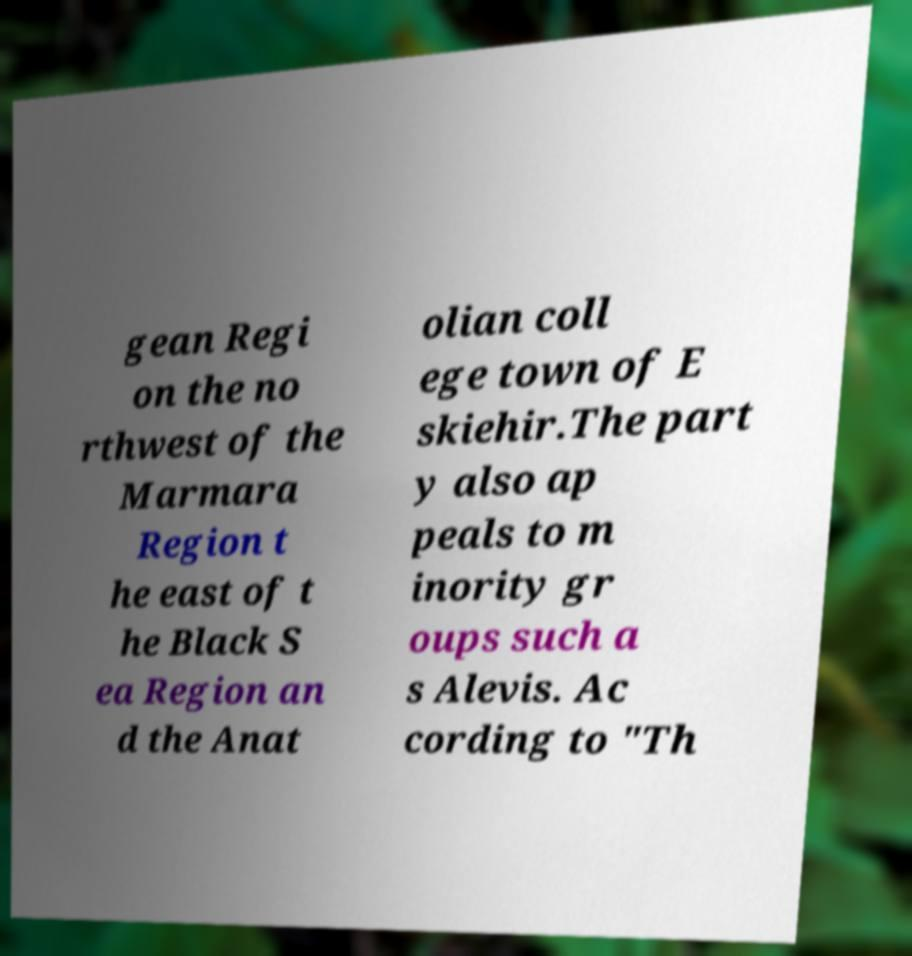I need the written content from this picture converted into text. Can you do that? gean Regi on the no rthwest of the Marmara Region t he east of t he Black S ea Region an d the Anat olian coll ege town of E skiehir.The part y also ap peals to m inority gr oups such a s Alevis. Ac cording to "Th 